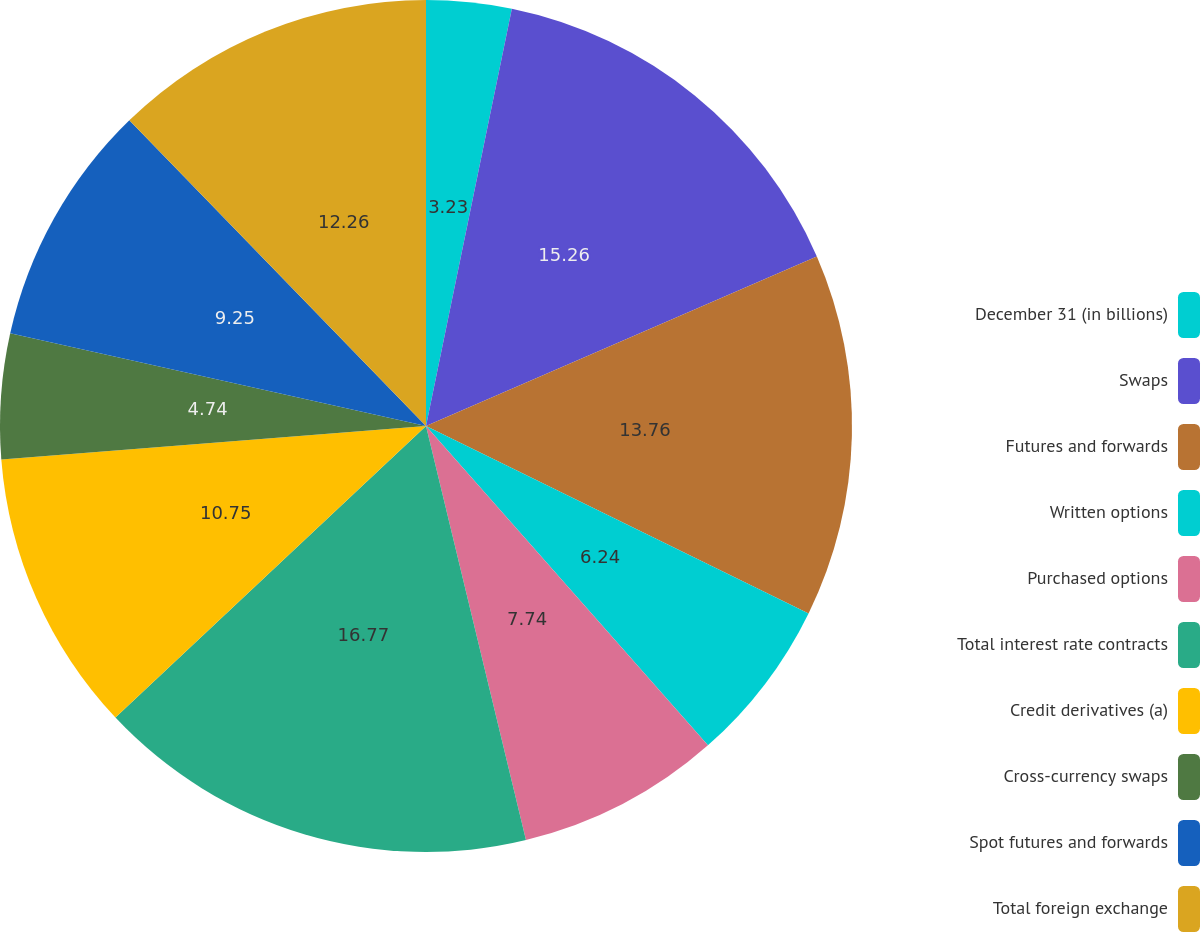Convert chart to OTSL. <chart><loc_0><loc_0><loc_500><loc_500><pie_chart><fcel>December 31 (in billions)<fcel>Swaps<fcel>Futures and forwards<fcel>Written options<fcel>Purchased options<fcel>Total interest rate contracts<fcel>Credit derivatives (a)<fcel>Cross-currency swaps<fcel>Spot futures and forwards<fcel>Total foreign exchange<nl><fcel>3.23%<fcel>15.26%<fcel>13.76%<fcel>6.24%<fcel>7.74%<fcel>16.77%<fcel>10.75%<fcel>4.74%<fcel>9.25%<fcel>12.26%<nl></chart> 